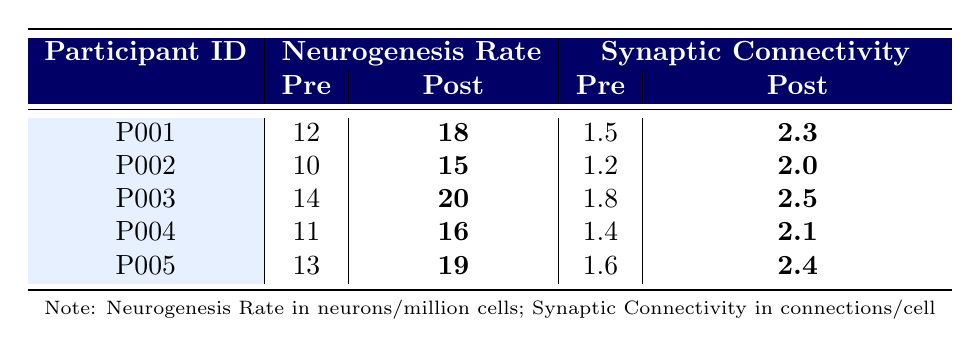What is the Post-Intervention Neurogenesis Rate for Participant P001? The table shows that the Post-Intervention Neurogenesis Rate for Participant P001 is highlighted as **18 neurons/million cells**.
Answer: 18 neurons/million cells What was the difference in Synaptic Connectivity for Participant P002 before and after the intervention? The pre-intervention value for Participant P002 is 1.2 connections/cell, and the post-intervention value is **2.0 connections/cell**. The difference is 2.0 - 1.2 = 0.8.
Answer: 0.8 connections/cell What was the highest Pre-Intervention Neurogenesis Rate among the participants? Reviewing the table, the Pre-Intervention Neurogenesis Rates are 12, 10, 14, 11, and 13 neurons/million cells. The highest value is 14 neurons/million cells for Participant P003.
Answer: 14 neurons/million cells Did any participant show a decrease in Synaptic Connectivity after the intervention? Analyzing the post-intervention values for Synaptic Connectivity, they are all greater than the pre-intervention values, indicating no decrease.
Answer: No What is the average Post-Intervention Neurogenesis Rate across all participants? The Post-Intervention Neurogenesis Rates are **18, 15, 20, 16, 19** neurons/million cells. To find the average, sum them up: 18 + 15 + 20 + 16 + 19 = 88, and then divide by 5, resulting in 88 / 5 = 17.6 neurons/million cells.
Answer: 17.6 neurons/million cells Which participant showed the greatest improvement in Synaptic Connectivity? The improvements in Synaptic Connectivity are: from 1.5 to **2.3** (P001; increase of 0.8), from 1.2 to **2.0** (P002; increase of 0.8), from 1.8 to **2.5** (P003; increase of 0.7), from 1.4 to **2.1** (P004; increase of 0.7), and from 1.6 to **2.4** (P005; increase of 0.8). P001 has the highest improvement at 0.8, which is tied with P002 and P005.
Answer: P001, P002, and P005 (all increased by 0.8) What is the overall trend in Neurogenesis Rate before and after the intervention? Upon examining the data, all participants show increased values in their Neurogenesis Rates post-intervention. Therefore, the overall trend is a positive increase.
Answer: Positive increase 